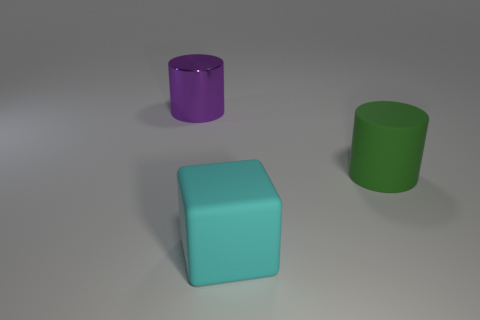Add 2 large brown shiny cubes. How many objects exist? 5 Subtract all cylinders. How many objects are left? 1 Add 1 large purple metal things. How many large purple metal things exist? 2 Subtract 0 green spheres. How many objects are left? 3 Subtract all tiny purple cubes. Subtract all large cyan things. How many objects are left? 2 Add 1 large green things. How many large green things are left? 2 